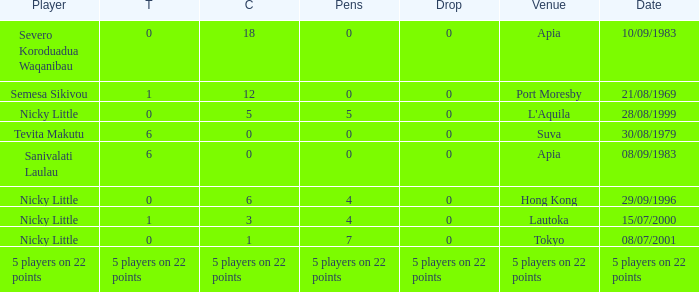How many drops did Nicky Little have in Hong Kong? 0.0. 